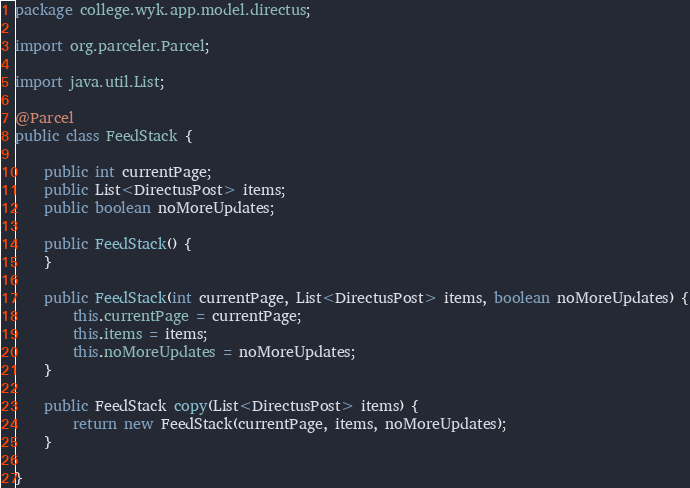Convert code to text. <code><loc_0><loc_0><loc_500><loc_500><_Java_>package college.wyk.app.model.directus;

import org.parceler.Parcel;

import java.util.List;

@Parcel
public class FeedStack {

    public int currentPage;
    public List<DirectusPost> items;
    public boolean noMoreUpdates;

    public FeedStack() {
    }

    public FeedStack(int currentPage, List<DirectusPost> items, boolean noMoreUpdates) {
        this.currentPage = currentPage;
        this.items = items;
        this.noMoreUpdates = noMoreUpdates;
    }

    public FeedStack copy(List<DirectusPost> items) {
        return new FeedStack(currentPage, items, noMoreUpdates);
    }

}
</code> 